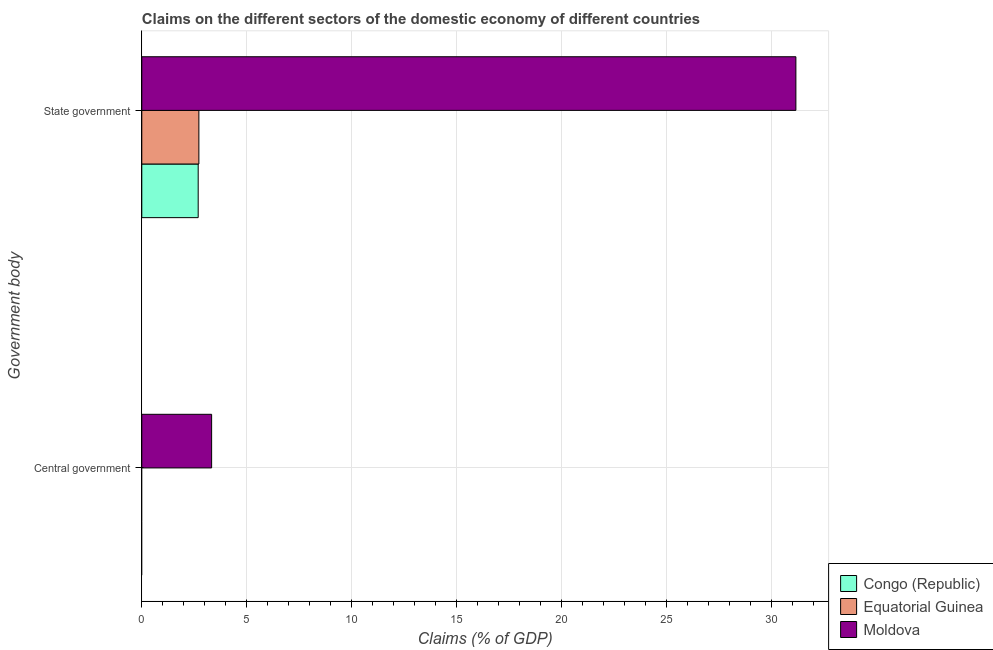Are the number of bars on each tick of the Y-axis equal?
Offer a terse response. No. How many bars are there on the 1st tick from the top?
Your answer should be compact. 3. How many bars are there on the 1st tick from the bottom?
Your answer should be compact. 1. What is the label of the 1st group of bars from the top?
Your response must be concise. State government. What is the claims on central government in Moldova?
Offer a terse response. 3.33. Across all countries, what is the maximum claims on central government?
Offer a terse response. 3.33. Across all countries, what is the minimum claims on state government?
Your response must be concise. 2.69. In which country was the claims on state government maximum?
Offer a very short reply. Moldova. What is the total claims on central government in the graph?
Keep it short and to the point. 3.33. What is the difference between the claims on state government in Equatorial Guinea and that in Congo (Republic)?
Ensure brevity in your answer.  0.03. What is the difference between the claims on state government in Equatorial Guinea and the claims on central government in Congo (Republic)?
Make the answer very short. 2.72. What is the average claims on state government per country?
Your answer should be compact. 12.2. What is the difference between the claims on central government and claims on state government in Moldova?
Offer a terse response. -27.85. In how many countries, is the claims on state government greater than 16 %?
Your answer should be very brief. 1. What is the ratio of the claims on state government in Equatorial Guinea to that in Moldova?
Provide a short and direct response. 0.09. How many bars are there?
Ensure brevity in your answer.  4. Does the graph contain any zero values?
Give a very brief answer. Yes. Does the graph contain grids?
Provide a short and direct response. Yes. Where does the legend appear in the graph?
Keep it short and to the point. Bottom right. What is the title of the graph?
Keep it short and to the point. Claims on the different sectors of the domestic economy of different countries. What is the label or title of the X-axis?
Provide a short and direct response. Claims (% of GDP). What is the label or title of the Y-axis?
Offer a terse response. Government body. What is the Claims (% of GDP) in Equatorial Guinea in Central government?
Provide a succinct answer. 0. What is the Claims (% of GDP) of Moldova in Central government?
Your answer should be compact. 3.33. What is the Claims (% of GDP) of Congo (Republic) in State government?
Your answer should be very brief. 2.69. What is the Claims (% of GDP) in Equatorial Guinea in State government?
Offer a very short reply. 2.72. What is the Claims (% of GDP) in Moldova in State government?
Give a very brief answer. 31.18. Across all Government body, what is the maximum Claims (% of GDP) of Congo (Republic)?
Provide a short and direct response. 2.69. Across all Government body, what is the maximum Claims (% of GDP) of Equatorial Guinea?
Give a very brief answer. 2.72. Across all Government body, what is the maximum Claims (% of GDP) of Moldova?
Your response must be concise. 31.18. Across all Government body, what is the minimum Claims (% of GDP) of Equatorial Guinea?
Make the answer very short. 0. Across all Government body, what is the minimum Claims (% of GDP) of Moldova?
Make the answer very short. 3.33. What is the total Claims (% of GDP) of Congo (Republic) in the graph?
Give a very brief answer. 2.69. What is the total Claims (% of GDP) of Equatorial Guinea in the graph?
Provide a succinct answer. 2.72. What is the total Claims (% of GDP) of Moldova in the graph?
Your answer should be very brief. 34.51. What is the difference between the Claims (% of GDP) in Moldova in Central government and that in State government?
Make the answer very short. -27.85. What is the average Claims (% of GDP) of Congo (Republic) per Government body?
Provide a short and direct response. 1.34. What is the average Claims (% of GDP) in Equatorial Guinea per Government body?
Offer a very short reply. 1.36. What is the average Claims (% of GDP) of Moldova per Government body?
Offer a terse response. 17.25. What is the difference between the Claims (% of GDP) of Congo (Republic) and Claims (% of GDP) of Equatorial Guinea in State government?
Your answer should be very brief. -0.03. What is the difference between the Claims (% of GDP) of Congo (Republic) and Claims (% of GDP) of Moldova in State government?
Your response must be concise. -28.49. What is the difference between the Claims (% of GDP) in Equatorial Guinea and Claims (% of GDP) in Moldova in State government?
Make the answer very short. -28.46. What is the ratio of the Claims (% of GDP) in Moldova in Central government to that in State government?
Give a very brief answer. 0.11. What is the difference between the highest and the second highest Claims (% of GDP) of Moldova?
Make the answer very short. 27.85. What is the difference between the highest and the lowest Claims (% of GDP) of Congo (Republic)?
Offer a terse response. 2.69. What is the difference between the highest and the lowest Claims (% of GDP) in Equatorial Guinea?
Provide a short and direct response. 2.72. What is the difference between the highest and the lowest Claims (% of GDP) in Moldova?
Provide a succinct answer. 27.85. 